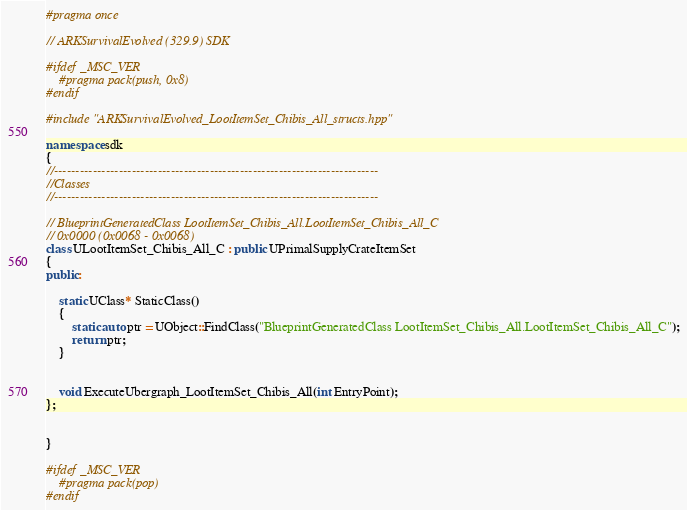<code> <loc_0><loc_0><loc_500><loc_500><_C++_>#pragma once

// ARKSurvivalEvolved (329.9) SDK

#ifdef _MSC_VER
	#pragma pack(push, 0x8)
#endif

#include "ARKSurvivalEvolved_LootItemSet_Chibis_All_structs.hpp"

namespace sdk
{
//---------------------------------------------------------------------------
//Classes
//---------------------------------------------------------------------------

// BlueprintGeneratedClass LootItemSet_Chibis_All.LootItemSet_Chibis_All_C
// 0x0000 (0x0068 - 0x0068)
class ULootItemSet_Chibis_All_C : public UPrimalSupplyCrateItemSet
{
public:

	static UClass* StaticClass()
	{
		static auto ptr = UObject::FindClass("BlueprintGeneratedClass LootItemSet_Chibis_All.LootItemSet_Chibis_All_C");
		return ptr;
	}


	void ExecuteUbergraph_LootItemSet_Chibis_All(int EntryPoint);
};


}

#ifdef _MSC_VER
	#pragma pack(pop)
#endif
</code> 